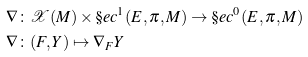<formula> <loc_0><loc_0><loc_500><loc_500>\nabla & \colon \mathcal { X } ( M ) \times \S e c ^ { 1 } ( E , \pi , M ) \to \S e c ^ { 0 } ( E , \pi , M ) \\ \nabla & \colon ( F , Y ) \mapsto \nabla _ { F } Y</formula> 